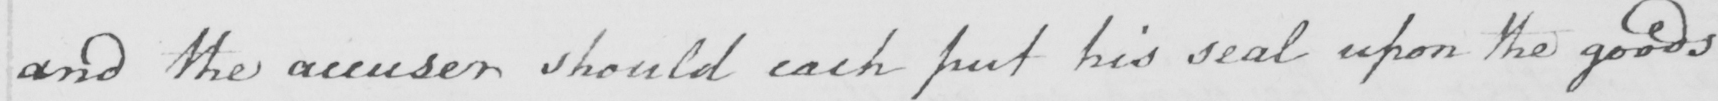Can you read and transcribe this handwriting? and the accuser should each put his seal upon the goods 